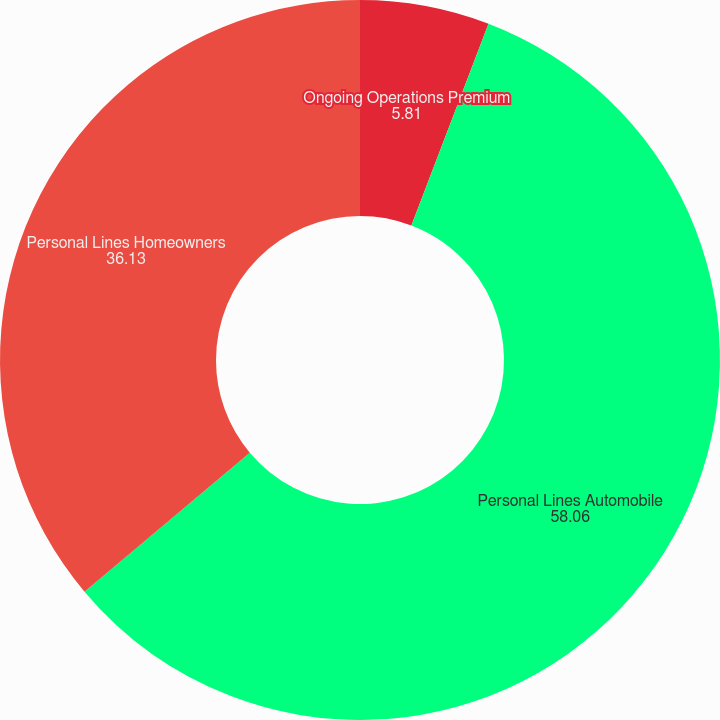<chart> <loc_0><loc_0><loc_500><loc_500><pie_chart><fcel>Ongoing Operations Premium<fcel>Personal Lines Automobile<fcel>Personal Lines Homeowners<fcel>Business Insurance<nl><fcel>5.81%<fcel>58.06%<fcel>36.13%<fcel>0.0%<nl></chart> 